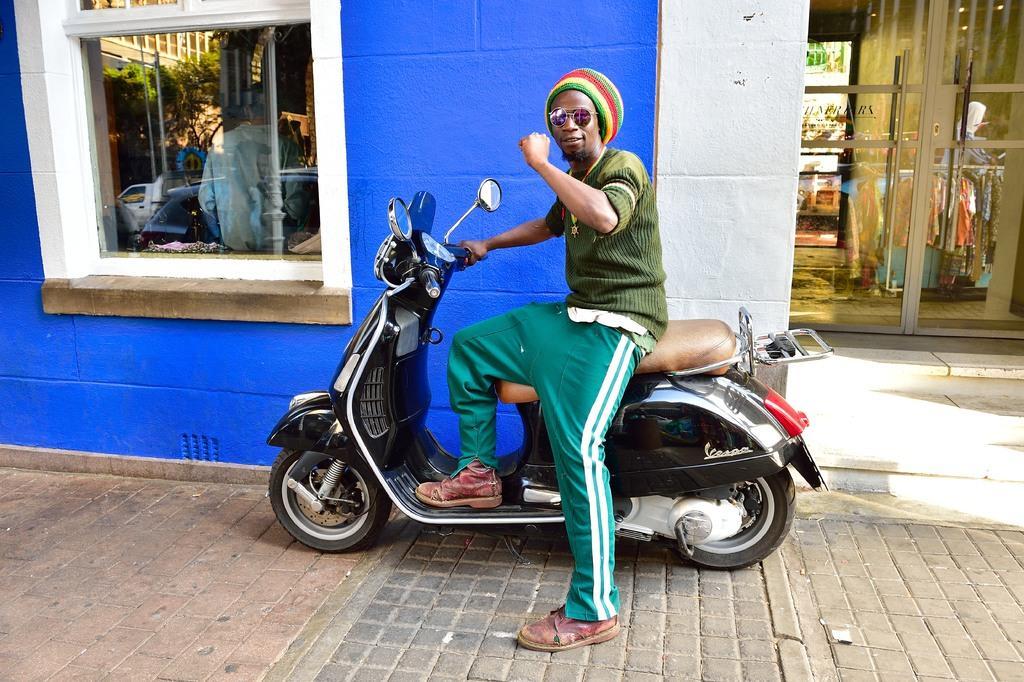Describe this image in one or two sentences. a person is sitting on a scooter. behind him there is a blue wall, a window and a door. 